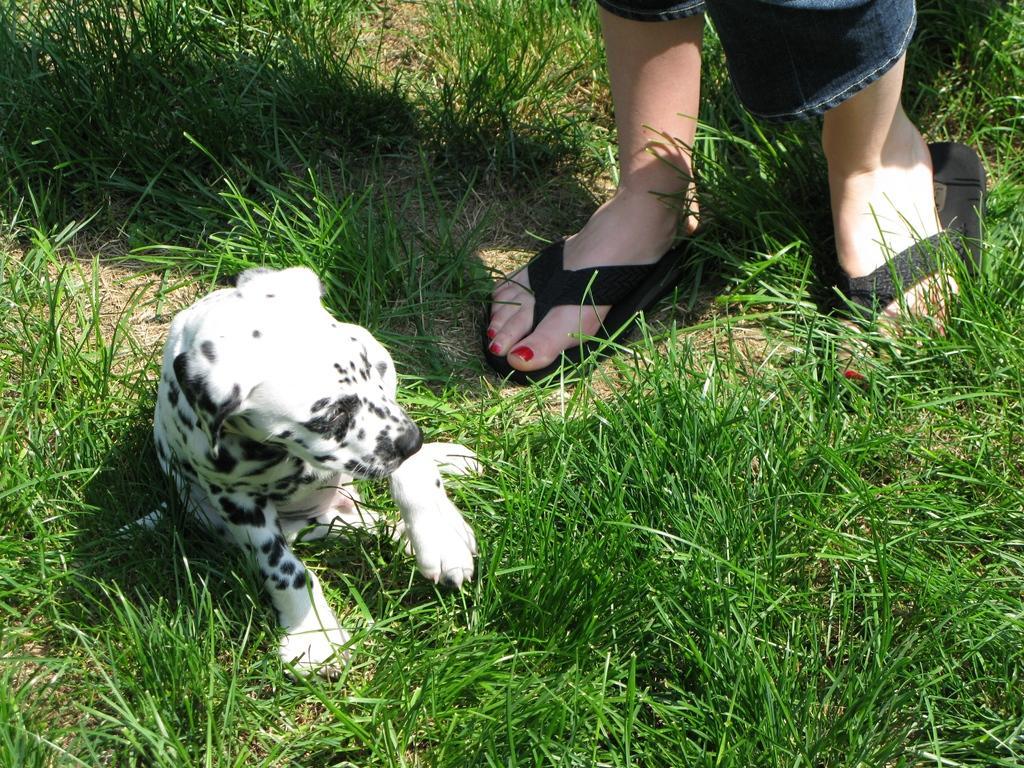How would you summarize this image in a sentence or two? In this image there is a dog sitting on the grass beside that there is a person standing. 